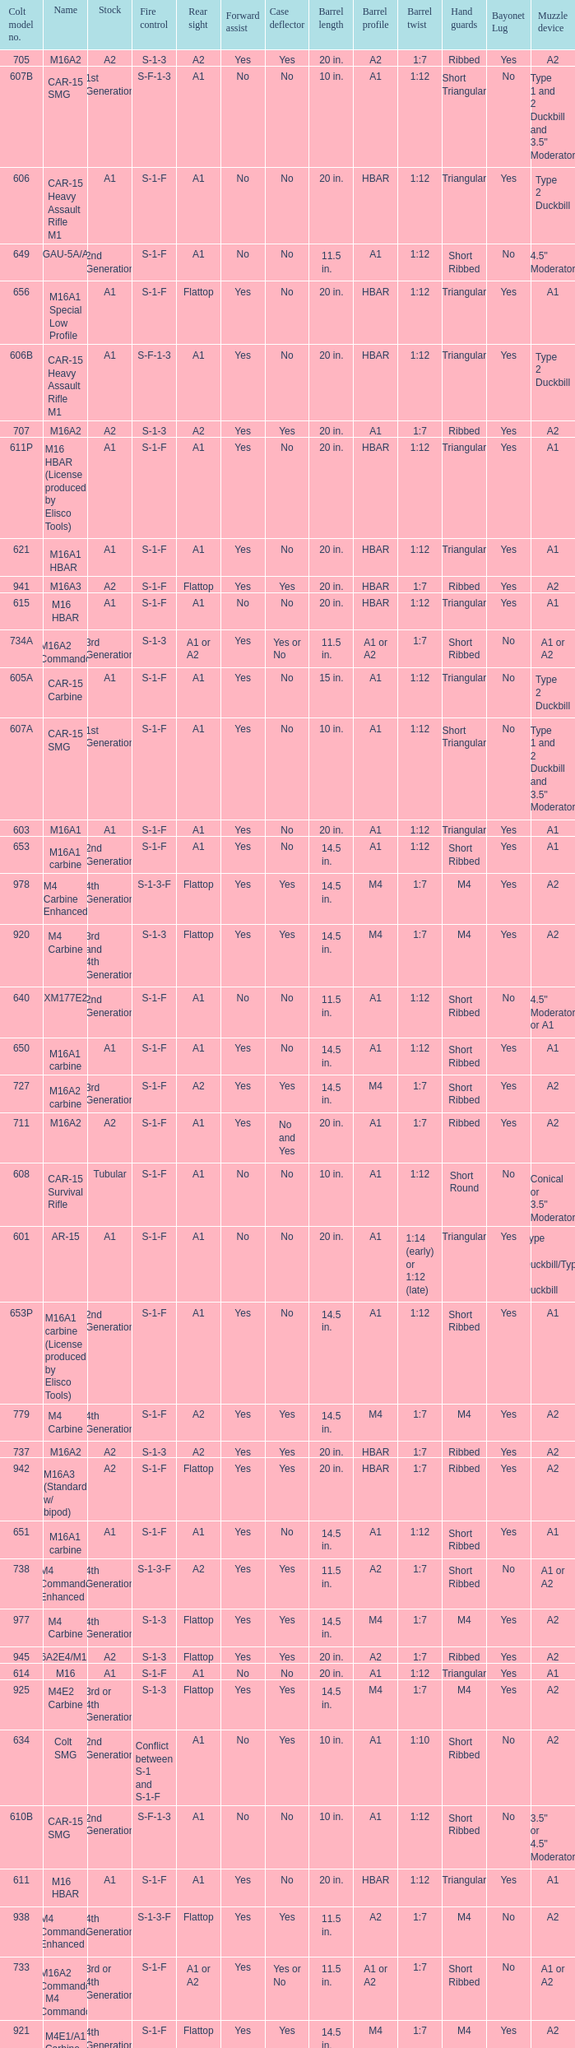What's the type of muzzle devices on the models with round hand guards? A1. 